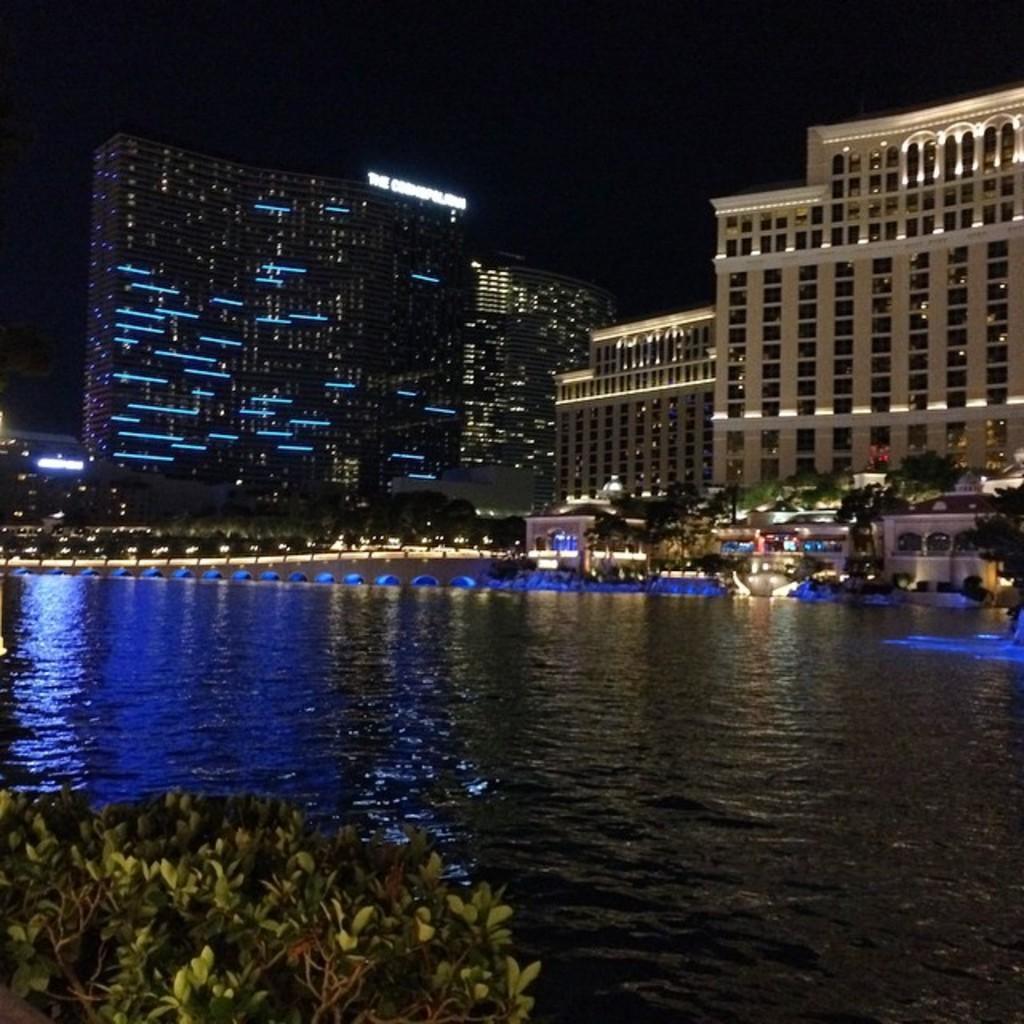Can you describe this image briefly? This is an image clicked in the dark. At the bottom, I can see the water and few plants. In the background there are many buildings, lights and trees in the dark. 